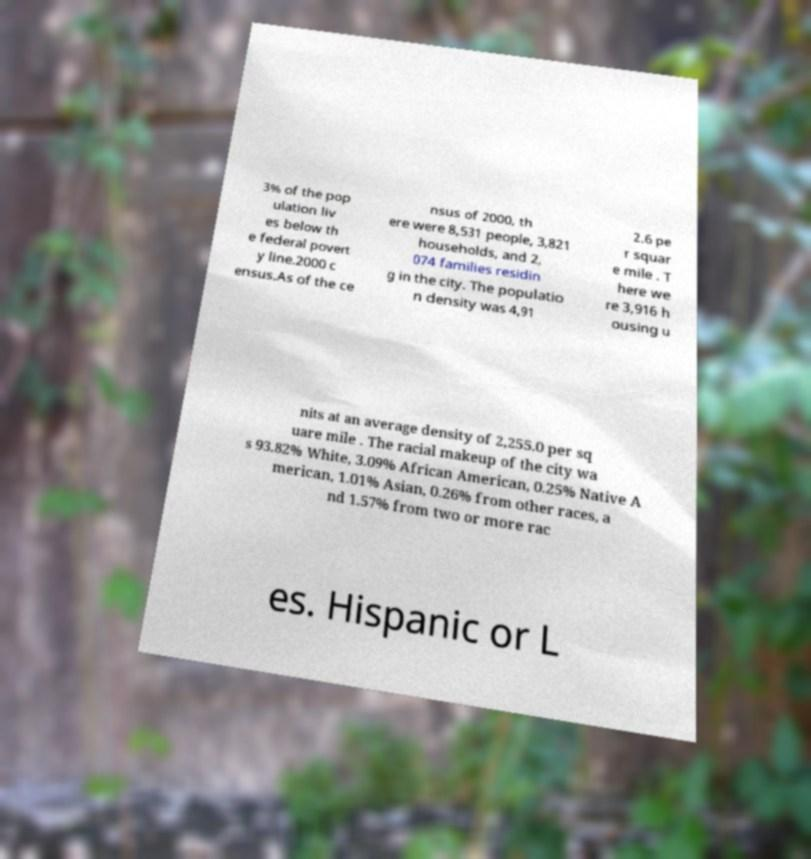For documentation purposes, I need the text within this image transcribed. Could you provide that? 3% of the pop ulation liv es below th e federal povert y line.2000 c ensus.As of the ce nsus of 2000, th ere were 8,531 people, 3,821 households, and 2, 074 families residin g in the city. The populatio n density was 4,91 2.6 pe r squar e mile . T here we re 3,916 h ousing u nits at an average density of 2,255.0 per sq uare mile . The racial makeup of the city wa s 93.82% White, 3.09% African American, 0.25% Native A merican, 1.01% Asian, 0.26% from other races, a nd 1.57% from two or more rac es. Hispanic or L 